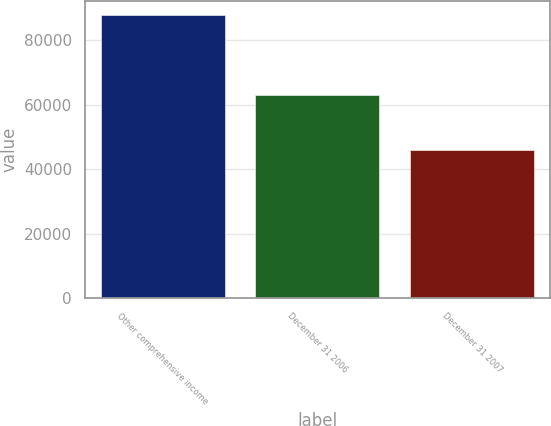Convert chart to OTSL. <chart><loc_0><loc_0><loc_500><loc_500><bar_chart><fcel>Other comprehensive income<fcel>December 31 2006<fcel>December 31 2007<nl><fcel>87901<fcel>63053<fcel>46075<nl></chart> 